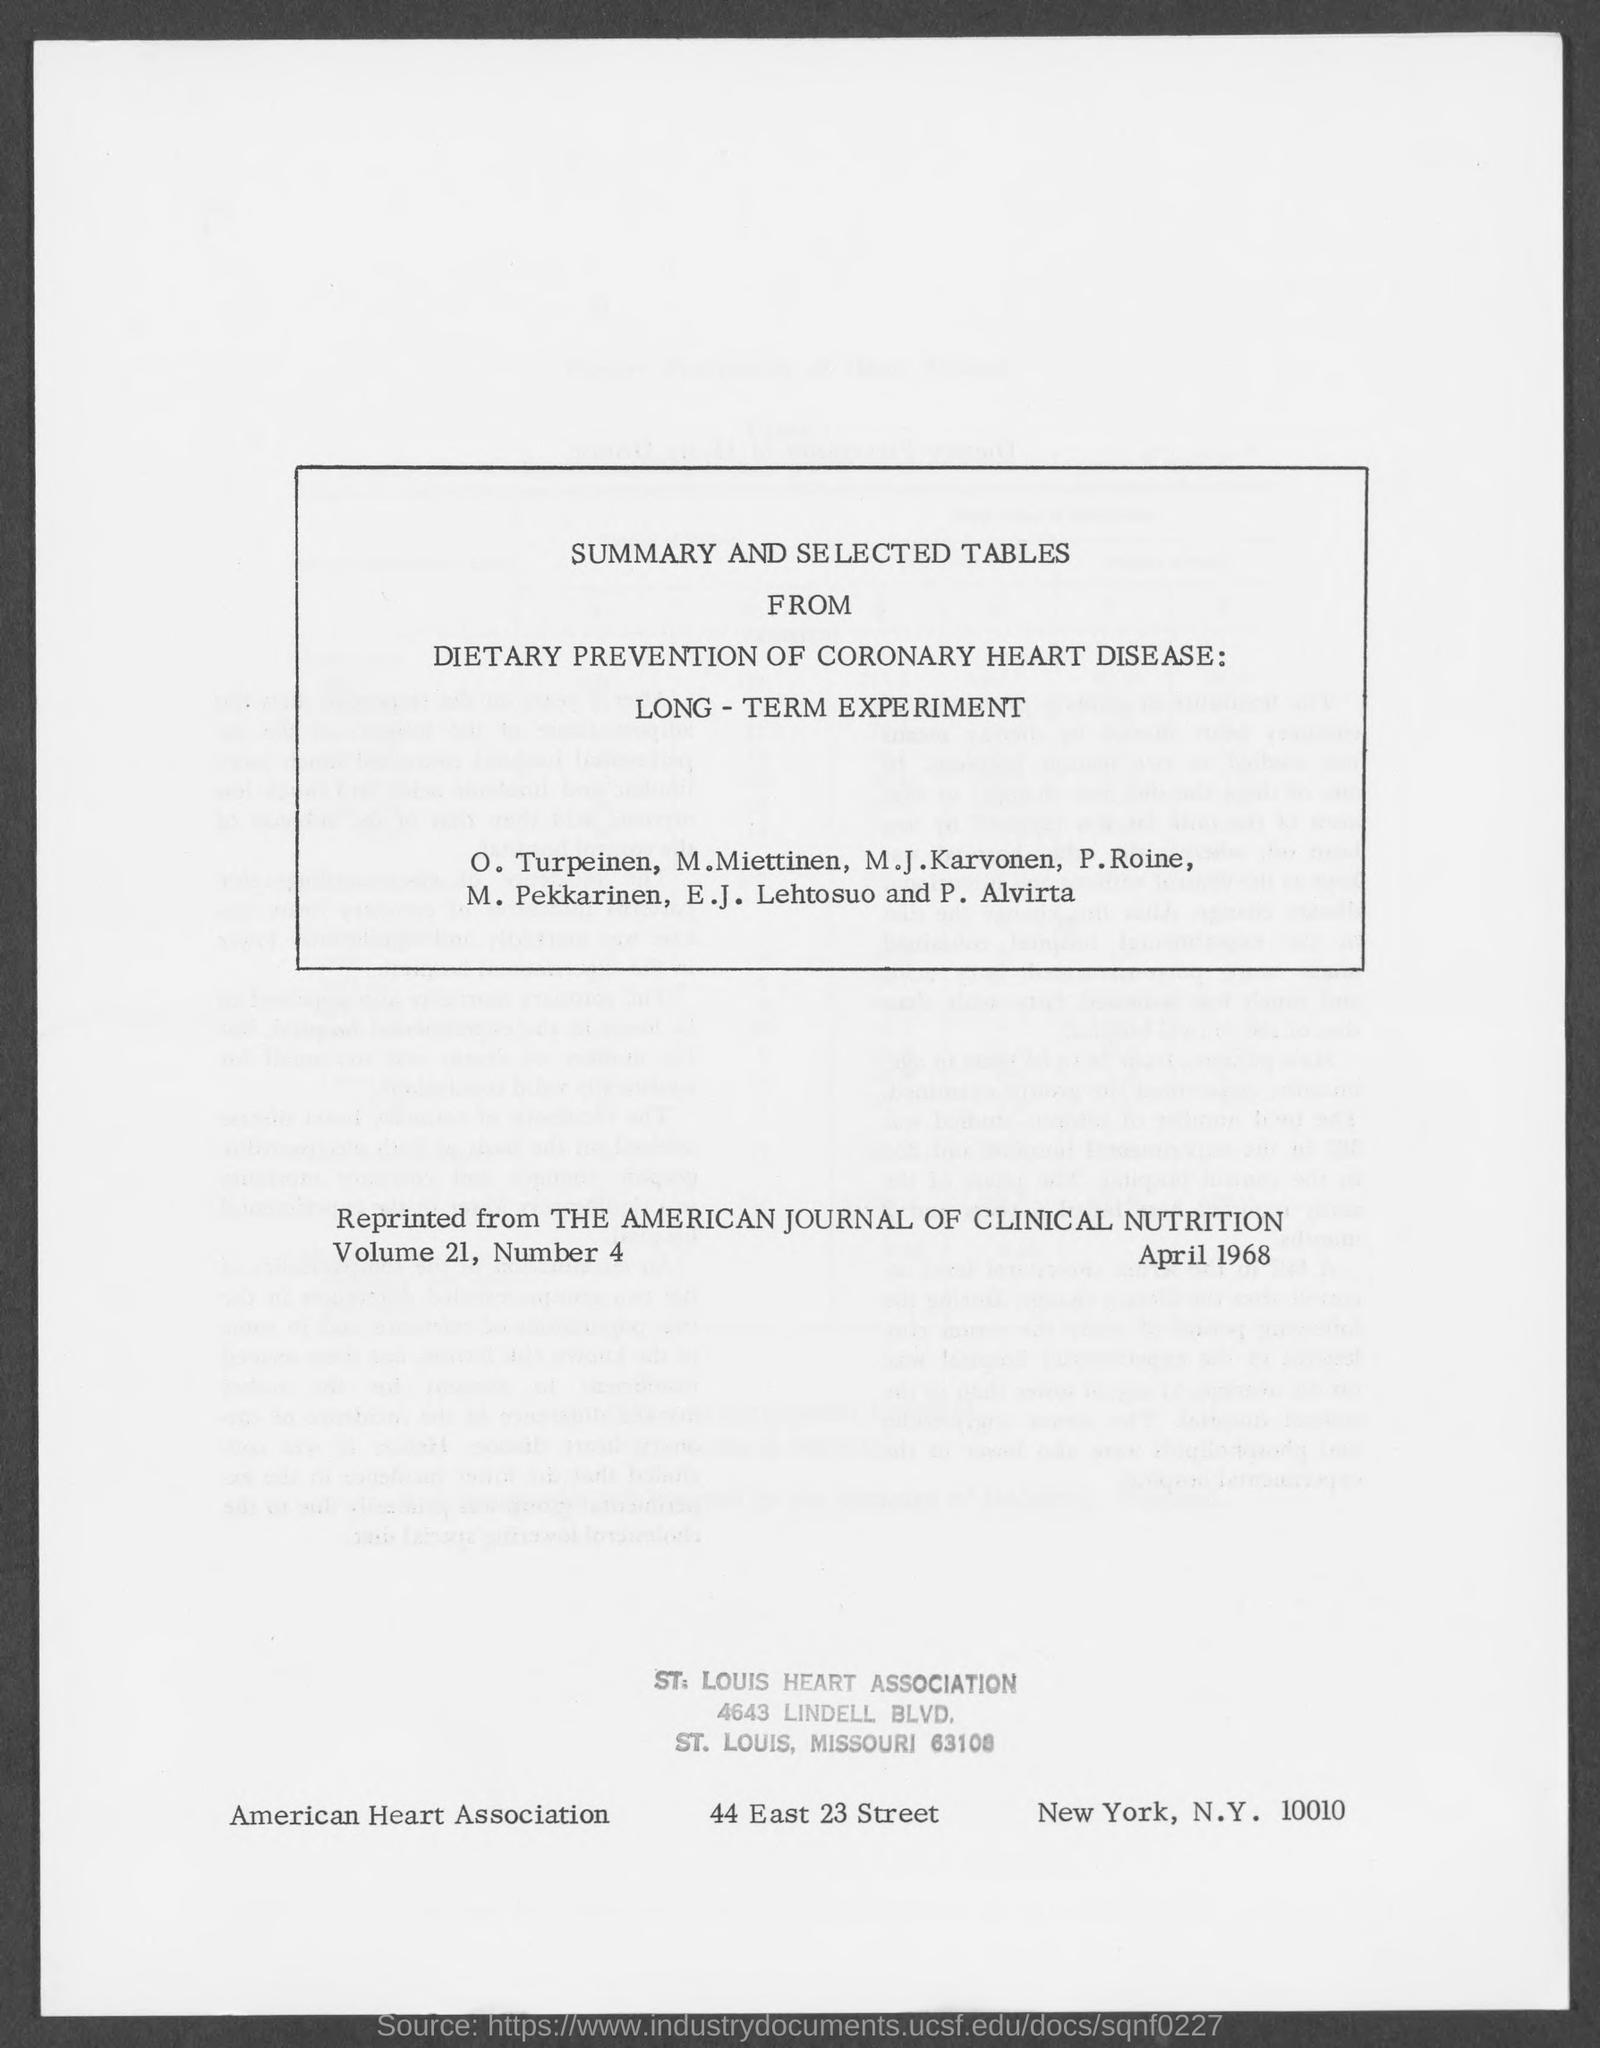Point out several critical features in this image. The American Heart Association has its street address located at 44 East 23 Street. The street address of the St. Louis Heart Association is 4643 Lindell Boulevard. 